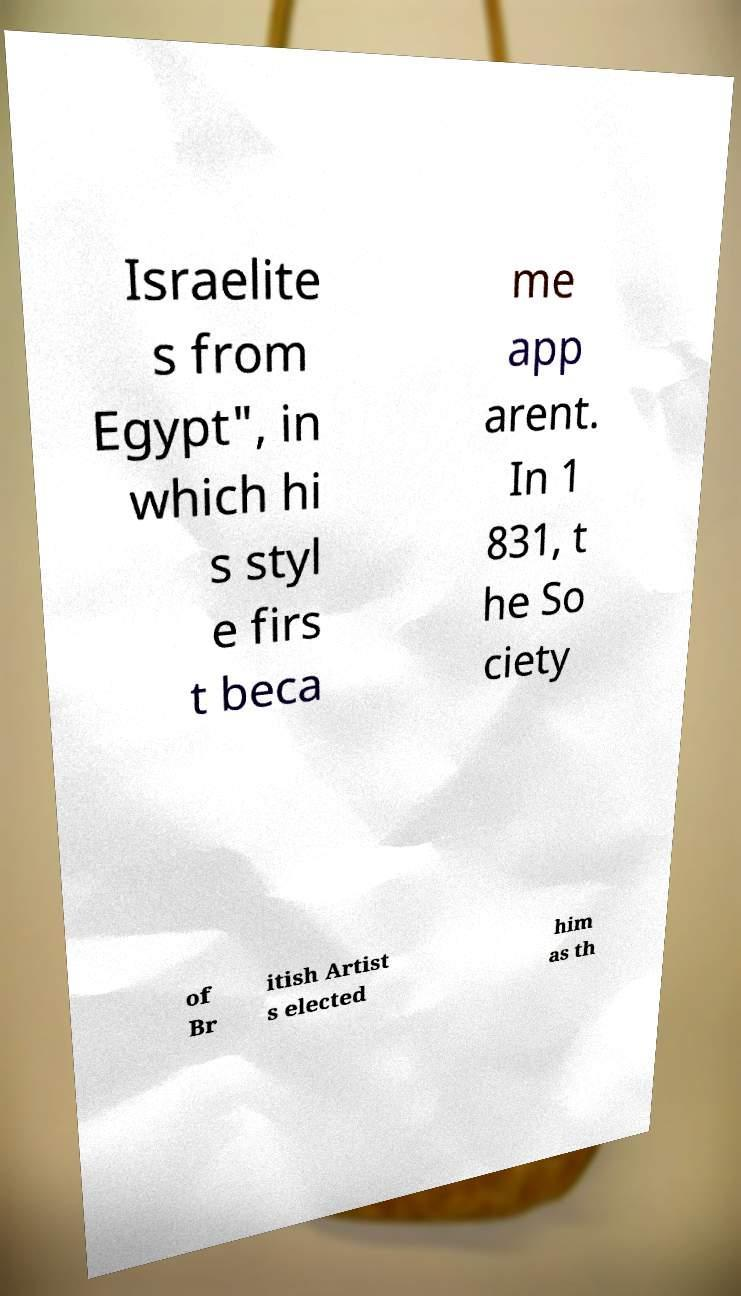Can you read and provide the text displayed in the image?This photo seems to have some interesting text. Can you extract and type it out for me? Israelite s from Egypt", in which hi s styl e firs t beca me app arent. In 1 831, t he So ciety of Br itish Artist s elected him as th 